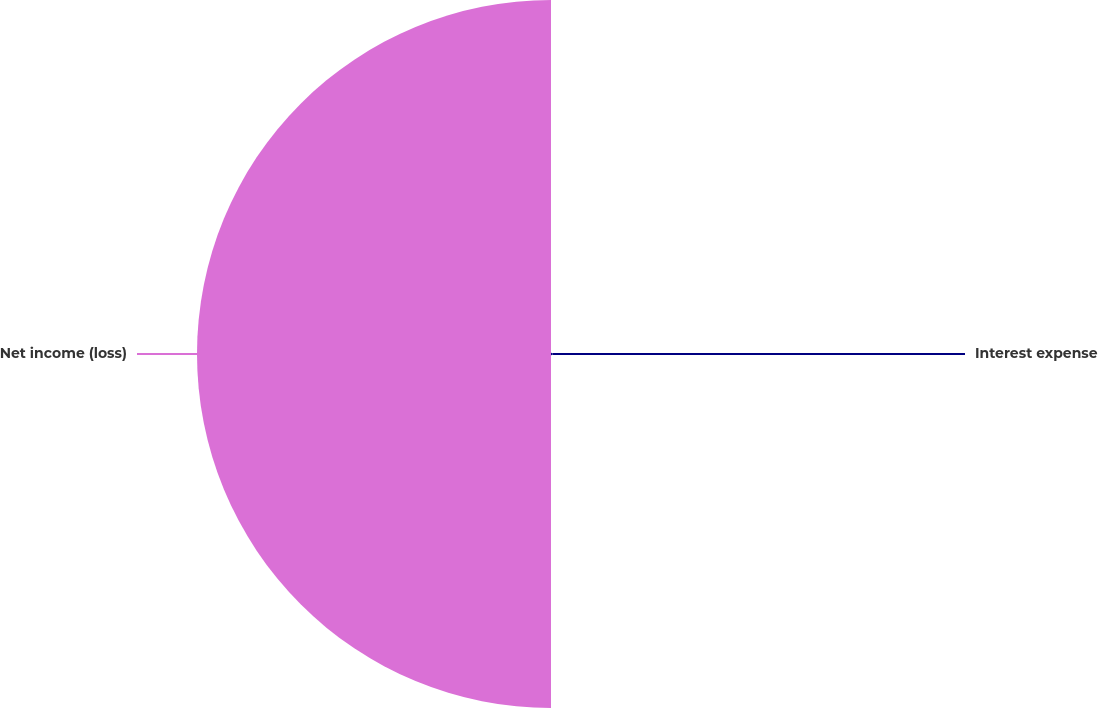Convert chart to OTSL. <chart><loc_0><loc_0><loc_500><loc_500><pie_chart><fcel>Interest expense<fcel>Net income (loss)<nl><fcel>0.38%<fcel>99.62%<nl></chart> 